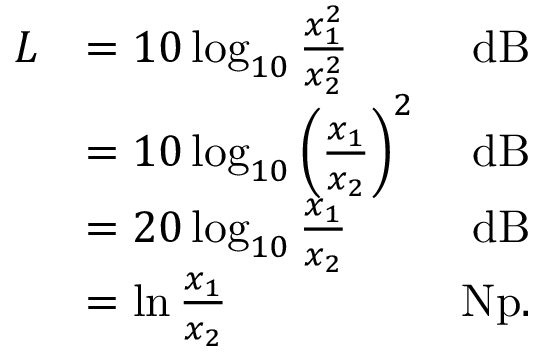<formula> <loc_0><loc_0><loc_500><loc_500>{ \begin{array} { r l r } { L } & { = 1 0 \log _ { 1 0 } { \frac { x _ { 1 } ^ { 2 } } { x _ { 2 } ^ { 2 } } } } & { d B } \\ & { = 1 0 \log _ { 1 0 } { \left ( { \frac { x _ { 1 } } { x _ { 2 } } } \right ) } ^ { 2 } } & { d B } \\ & { = 2 0 \log _ { 1 0 } { \frac { x _ { 1 } } { x _ { 2 } } } } & { d B } \\ & { = \ln { \frac { x _ { 1 } } { x _ { 2 } } } } & { { N p } . } \end{array} }</formula> 